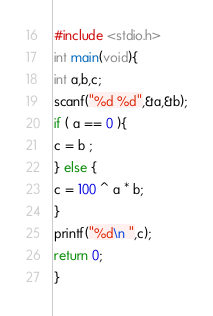<code> <loc_0><loc_0><loc_500><loc_500><_C_>#include <stdio.h>
int main(void){
int a,b,c;
scanf("%d %d",&a,&b);
if ( a == 0 ){
c = b ;
} else {
c = 100 ^ a * b;
}
printf("%d\n ",c);
return 0;
}
</code> 